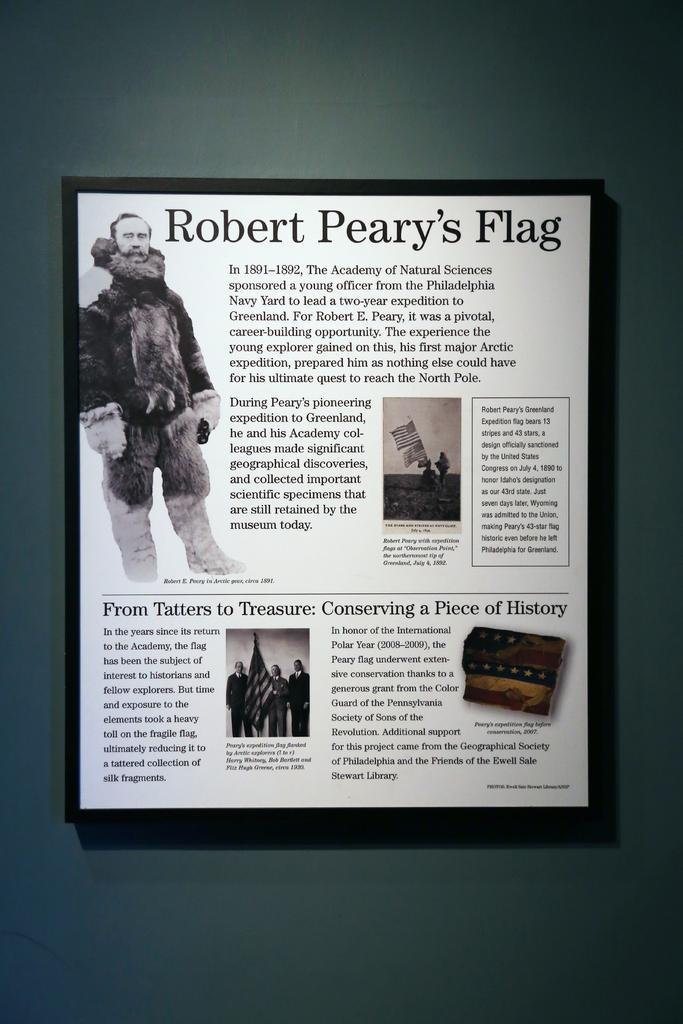Describe this image in one or two sentences. Here in this picture we can see a portrait present on a wall and in that we can see pictures present and we can also see text present. 